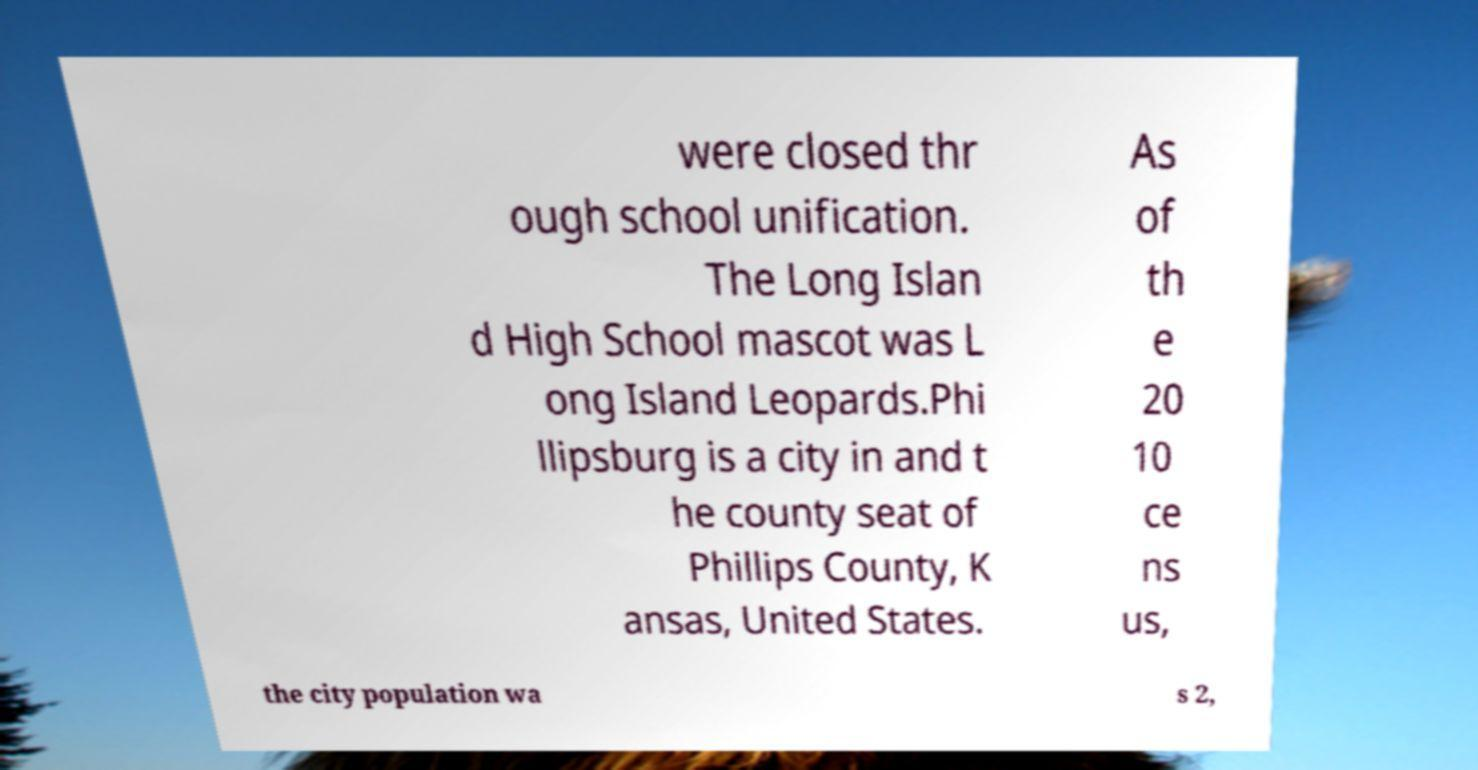I need the written content from this picture converted into text. Can you do that? were closed thr ough school unification. The Long Islan d High School mascot was L ong Island Leopards.Phi llipsburg is a city in and t he county seat of Phillips County, K ansas, United States. As of th e 20 10 ce ns us, the city population wa s 2, 